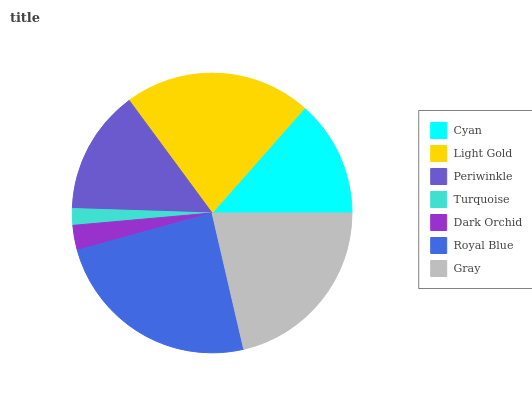Is Turquoise the minimum?
Answer yes or no. Yes. Is Royal Blue the maximum?
Answer yes or no. Yes. Is Light Gold the minimum?
Answer yes or no. No. Is Light Gold the maximum?
Answer yes or no. No. Is Light Gold greater than Cyan?
Answer yes or no. Yes. Is Cyan less than Light Gold?
Answer yes or no. Yes. Is Cyan greater than Light Gold?
Answer yes or no. No. Is Light Gold less than Cyan?
Answer yes or no. No. Is Periwinkle the high median?
Answer yes or no. Yes. Is Periwinkle the low median?
Answer yes or no. Yes. Is Gray the high median?
Answer yes or no. No. Is Dark Orchid the low median?
Answer yes or no. No. 